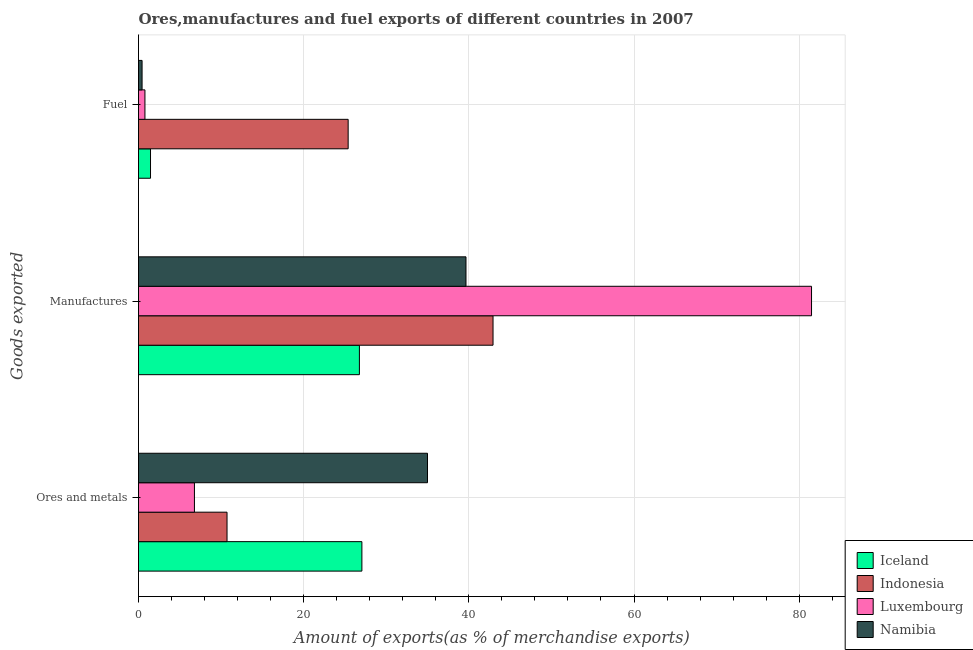How many bars are there on the 3rd tick from the top?
Your answer should be compact. 4. What is the label of the 3rd group of bars from the top?
Offer a very short reply. Ores and metals. What is the percentage of manufactures exports in Luxembourg?
Offer a very short reply. 81.5. Across all countries, what is the maximum percentage of ores and metals exports?
Keep it short and to the point. 34.99. Across all countries, what is the minimum percentage of ores and metals exports?
Keep it short and to the point. 6.77. In which country was the percentage of manufactures exports maximum?
Make the answer very short. Luxembourg. In which country was the percentage of fuel exports minimum?
Your answer should be compact. Namibia. What is the total percentage of ores and metals exports in the graph?
Keep it short and to the point. 79.54. What is the difference between the percentage of fuel exports in Indonesia and that in Iceland?
Provide a succinct answer. 23.93. What is the difference between the percentage of ores and metals exports in Namibia and the percentage of fuel exports in Iceland?
Provide a succinct answer. 33.54. What is the average percentage of fuel exports per country?
Keep it short and to the point. 7.01. What is the difference between the percentage of manufactures exports and percentage of fuel exports in Namibia?
Keep it short and to the point. 39.22. What is the ratio of the percentage of ores and metals exports in Indonesia to that in Iceland?
Ensure brevity in your answer.  0.4. Is the percentage of manufactures exports in Namibia less than that in Luxembourg?
Offer a very short reply. Yes. Is the difference between the percentage of fuel exports in Luxembourg and Indonesia greater than the difference between the percentage of manufactures exports in Luxembourg and Indonesia?
Make the answer very short. No. What is the difference between the highest and the second highest percentage of ores and metals exports?
Offer a terse response. 7.94. What is the difference between the highest and the lowest percentage of ores and metals exports?
Your response must be concise. 28.22. Is the sum of the percentage of manufactures exports in Iceland and Indonesia greater than the maximum percentage of fuel exports across all countries?
Your answer should be compact. Yes. What does the 4th bar from the top in Manufactures represents?
Keep it short and to the point. Iceland. Is it the case that in every country, the sum of the percentage of ores and metals exports and percentage of manufactures exports is greater than the percentage of fuel exports?
Your answer should be compact. Yes. How many bars are there?
Provide a short and direct response. 12. What is the difference between two consecutive major ticks on the X-axis?
Offer a terse response. 20. Are the values on the major ticks of X-axis written in scientific E-notation?
Provide a short and direct response. No. What is the title of the graph?
Your response must be concise. Ores,manufactures and fuel exports of different countries in 2007. Does "Paraguay" appear as one of the legend labels in the graph?
Your answer should be very brief. No. What is the label or title of the X-axis?
Offer a terse response. Amount of exports(as % of merchandise exports). What is the label or title of the Y-axis?
Your answer should be compact. Goods exported. What is the Amount of exports(as % of merchandise exports) in Iceland in Ores and metals?
Your answer should be compact. 27.05. What is the Amount of exports(as % of merchandise exports) in Indonesia in Ores and metals?
Offer a terse response. 10.72. What is the Amount of exports(as % of merchandise exports) in Luxembourg in Ores and metals?
Offer a very short reply. 6.77. What is the Amount of exports(as % of merchandise exports) of Namibia in Ores and metals?
Your answer should be compact. 34.99. What is the Amount of exports(as % of merchandise exports) in Iceland in Manufactures?
Offer a terse response. 26.75. What is the Amount of exports(as % of merchandise exports) of Indonesia in Manufactures?
Provide a succinct answer. 42.93. What is the Amount of exports(as % of merchandise exports) of Luxembourg in Manufactures?
Make the answer very short. 81.5. What is the Amount of exports(as % of merchandise exports) in Namibia in Manufactures?
Give a very brief answer. 39.66. What is the Amount of exports(as % of merchandise exports) of Iceland in Fuel?
Give a very brief answer. 1.45. What is the Amount of exports(as % of merchandise exports) of Indonesia in Fuel?
Provide a succinct answer. 25.39. What is the Amount of exports(as % of merchandise exports) in Luxembourg in Fuel?
Give a very brief answer. 0.78. What is the Amount of exports(as % of merchandise exports) in Namibia in Fuel?
Give a very brief answer. 0.43. Across all Goods exported, what is the maximum Amount of exports(as % of merchandise exports) of Iceland?
Offer a terse response. 27.05. Across all Goods exported, what is the maximum Amount of exports(as % of merchandise exports) of Indonesia?
Make the answer very short. 42.93. Across all Goods exported, what is the maximum Amount of exports(as % of merchandise exports) in Luxembourg?
Give a very brief answer. 81.5. Across all Goods exported, what is the maximum Amount of exports(as % of merchandise exports) in Namibia?
Your answer should be very brief. 39.66. Across all Goods exported, what is the minimum Amount of exports(as % of merchandise exports) in Iceland?
Ensure brevity in your answer.  1.45. Across all Goods exported, what is the minimum Amount of exports(as % of merchandise exports) in Indonesia?
Your answer should be compact. 10.72. Across all Goods exported, what is the minimum Amount of exports(as % of merchandise exports) of Luxembourg?
Ensure brevity in your answer.  0.78. Across all Goods exported, what is the minimum Amount of exports(as % of merchandise exports) of Namibia?
Offer a terse response. 0.43. What is the total Amount of exports(as % of merchandise exports) in Iceland in the graph?
Make the answer very short. 55.25. What is the total Amount of exports(as % of merchandise exports) of Indonesia in the graph?
Give a very brief answer. 79.04. What is the total Amount of exports(as % of merchandise exports) in Luxembourg in the graph?
Your answer should be compact. 89.05. What is the total Amount of exports(as % of merchandise exports) in Namibia in the graph?
Your answer should be very brief. 75.08. What is the difference between the Amount of exports(as % of merchandise exports) in Iceland in Ores and metals and that in Manufactures?
Your answer should be compact. 0.3. What is the difference between the Amount of exports(as % of merchandise exports) in Indonesia in Ores and metals and that in Manufactures?
Offer a very short reply. -32.21. What is the difference between the Amount of exports(as % of merchandise exports) in Luxembourg in Ores and metals and that in Manufactures?
Provide a short and direct response. -74.73. What is the difference between the Amount of exports(as % of merchandise exports) of Namibia in Ores and metals and that in Manufactures?
Keep it short and to the point. -4.66. What is the difference between the Amount of exports(as % of merchandise exports) of Iceland in Ores and metals and that in Fuel?
Make the answer very short. 25.6. What is the difference between the Amount of exports(as % of merchandise exports) in Indonesia in Ores and metals and that in Fuel?
Your answer should be compact. -14.67. What is the difference between the Amount of exports(as % of merchandise exports) in Luxembourg in Ores and metals and that in Fuel?
Keep it short and to the point. 5.99. What is the difference between the Amount of exports(as % of merchandise exports) in Namibia in Ores and metals and that in Fuel?
Your answer should be compact. 34.56. What is the difference between the Amount of exports(as % of merchandise exports) of Iceland in Manufactures and that in Fuel?
Provide a succinct answer. 25.3. What is the difference between the Amount of exports(as % of merchandise exports) of Indonesia in Manufactures and that in Fuel?
Offer a very short reply. 17.54. What is the difference between the Amount of exports(as % of merchandise exports) of Luxembourg in Manufactures and that in Fuel?
Keep it short and to the point. 80.72. What is the difference between the Amount of exports(as % of merchandise exports) in Namibia in Manufactures and that in Fuel?
Your answer should be very brief. 39.22. What is the difference between the Amount of exports(as % of merchandise exports) in Iceland in Ores and metals and the Amount of exports(as % of merchandise exports) in Indonesia in Manufactures?
Make the answer very short. -15.88. What is the difference between the Amount of exports(as % of merchandise exports) in Iceland in Ores and metals and the Amount of exports(as % of merchandise exports) in Luxembourg in Manufactures?
Offer a terse response. -54.45. What is the difference between the Amount of exports(as % of merchandise exports) of Iceland in Ores and metals and the Amount of exports(as % of merchandise exports) of Namibia in Manufactures?
Your response must be concise. -12.61. What is the difference between the Amount of exports(as % of merchandise exports) in Indonesia in Ores and metals and the Amount of exports(as % of merchandise exports) in Luxembourg in Manufactures?
Keep it short and to the point. -70.78. What is the difference between the Amount of exports(as % of merchandise exports) in Indonesia in Ores and metals and the Amount of exports(as % of merchandise exports) in Namibia in Manufactures?
Your answer should be compact. -28.94. What is the difference between the Amount of exports(as % of merchandise exports) in Luxembourg in Ores and metals and the Amount of exports(as % of merchandise exports) in Namibia in Manufactures?
Your answer should be compact. -32.88. What is the difference between the Amount of exports(as % of merchandise exports) in Iceland in Ores and metals and the Amount of exports(as % of merchandise exports) in Indonesia in Fuel?
Provide a succinct answer. 1.66. What is the difference between the Amount of exports(as % of merchandise exports) in Iceland in Ores and metals and the Amount of exports(as % of merchandise exports) in Luxembourg in Fuel?
Ensure brevity in your answer.  26.27. What is the difference between the Amount of exports(as % of merchandise exports) in Iceland in Ores and metals and the Amount of exports(as % of merchandise exports) in Namibia in Fuel?
Keep it short and to the point. 26.62. What is the difference between the Amount of exports(as % of merchandise exports) of Indonesia in Ores and metals and the Amount of exports(as % of merchandise exports) of Luxembourg in Fuel?
Your answer should be compact. 9.94. What is the difference between the Amount of exports(as % of merchandise exports) in Indonesia in Ores and metals and the Amount of exports(as % of merchandise exports) in Namibia in Fuel?
Provide a succinct answer. 10.29. What is the difference between the Amount of exports(as % of merchandise exports) in Luxembourg in Ores and metals and the Amount of exports(as % of merchandise exports) in Namibia in Fuel?
Your response must be concise. 6.34. What is the difference between the Amount of exports(as % of merchandise exports) of Iceland in Manufactures and the Amount of exports(as % of merchandise exports) of Indonesia in Fuel?
Your answer should be compact. 1.36. What is the difference between the Amount of exports(as % of merchandise exports) in Iceland in Manufactures and the Amount of exports(as % of merchandise exports) in Luxembourg in Fuel?
Provide a short and direct response. 25.97. What is the difference between the Amount of exports(as % of merchandise exports) in Iceland in Manufactures and the Amount of exports(as % of merchandise exports) in Namibia in Fuel?
Your answer should be compact. 26.32. What is the difference between the Amount of exports(as % of merchandise exports) in Indonesia in Manufactures and the Amount of exports(as % of merchandise exports) in Luxembourg in Fuel?
Your answer should be very brief. 42.15. What is the difference between the Amount of exports(as % of merchandise exports) of Indonesia in Manufactures and the Amount of exports(as % of merchandise exports) of Namibia in Fuel?
Give a very brief answer. 42.5. What is the difference between the Amount of exports(as % of merchandise exports) of Luxembourg in Manufactures and the Amount of exports(as % of merchandise exports) of Namibia in Fuel?
Offer a very short reply. 81.07. What is the average Amount of exports(as % of merchandise exports) in Iceland per Goods exported?
Offer a terse response. 18.42. What is the average Amount of exports(as % of merchandise exports) of Indonesia per Goods exported?
Provide a short and direct response. 26.35. What is the average Amount of exports(as % of merchandise exports) in Luxembourg per Goods exported?
Offer a very short reply. 29.68. What is the average Amount of exports(as % of merchandise exports) of Namibia per Goods exported?
Offer a terse response. 25.03. What is the difference between the Amount of exports(as % of merchandise exports) of Iceland and Amount of exports(as % of merchandise exports) of Indonesia in Ores and metals?
Offer a terse response. 16.33. What is the difference between the Amount of exports(as % of merchandise exports) of Iceland and Amount of exports(as % of merchandise exports) of Luxembourg in Ores and metals?
Offer a very short reply. 20.28. What is the difference between the Amount of exports(as % of merchandise exports) in Iceland and Amount of exports(as % of merchandise exports) in Namibia in Ores and metals?
Your answer should be very brief. -7.94. What is the difference between the Amount of exports(as % of merchandise exports) in Indonesia and Amount of exports(as % of merchandise exports) in Luxembourg in Ores and metals?
Give a very brief answer. 3.95. What is the difference between the Amount of exports(as % of merchandise exports) of Indonesia and Amount of exports(as % of merchandise exports) of Namibia in Ores and metals?
Ensure brevity in your answer.  -24.28. What is the difference between the Amount of exports(as % of merchandise exports) of Luxembourg and Amount of exports(as % of merchandise exports) of Namibia in Ores and metals?
Provide a succinct answer. -28.22. What is the difference between the Amount of exports(as % of merchandise exports) of Iceland and Amount of exports(as % of merchandise exports) of Indonesia in Manufactures?
Your answer should be very brief. -16.18. What is the difference between the Amount of exports(as % of merchandise exports) of Iceland and Amount of exports(as % of merchandise exports) of Luxembourg in Manufactures?
Your response must be concise. -54.75. What is the difference between the Amount of exports(as % of merchandise exports) of Iceland and Amount of exports(as % of merchandise exports) of Namibia in Manufactures?
Keep it short and to the point. -12.91. What is the difference between the Amount of exports(as % of merchandise exports) of Indonesia and Amount of exports(as % of merchandise exports) of Luxembourg in Manufactures?
Your answer should be compact. -38.57. What is the difference between the Amount of exports(as % of merchandise exports) of Indonesia and Amount of exports(as % of merchandise exports) of Namibia in Manufactures?
Keep it short and to the point. 3.27. What is the difference between the Amount of exports(as % of merchandise exports) in Luxembourg and Amount of exports(as % of merchandise exports) in Namibia in Manufactures?
Offer a terse response. 41.84. What is the difference between the Amount of exports(as % of merchandise exports) of Iceland and Amount of exports(as % of merchandise exports) of Indonesia in Fuel?
Keep it short and to the point. -23.93. What is the difference between the Amount of exports(as % of merchandise exports) of Iceland and Amount of exports(as % of merchandise exports) of Luxembourg in Fuel?
Your answer should be compact. 0.68. What is the difference between the Amount of exports(as % of merchandise exports) of Iceland and Amount of exports(as % of merchandise exports) of Namibia in Fuel?
Offer a very short reply. 1.02. What is the difference between the Amount of exports(as % of merchandise exports) of Indonesia and Amount of exports(as % of merchandise exports) of Luxembourg in Fuel?
Offer a very short reply. 24.61. What is the difference between the Amount of exports(as % of merchandise exports) in Indonesia and Amount of exports(as % of merchandise exports) in Namibia in Fuel?
Provide a succinct answer. 24.96. What is the difference between the Amount of exports(as % of merchandise exports) of Luxembourg and Amount of exports(as % of merchandise exports) of Namibia in Fuel?
Give a very brief answer. 0.35. What is the ratio of the Amount of exports(as % of merchandise exports) in Iceland in Ores and metals to that in Manufactures?
Your answer should be very brief. 1.01. What is the ratio of the Amount of exports(as % of merchandise exports) in Indonesia in Ores and metals to that in Manufactures?
Ensure brevity in your answer.  0.25. What is the ratio of the Amount of exports(as % of merchandise exports) of Luxembourg in Ores and metals to that in Manufactures?
Ensure brevity in your answer.  0.08. What is the ratio of the Amount of exports(as % of merchandise exports) in Namibia in Ores and metals to that in Manufactures?
Offer a very short reply. 0.88. What is the ratio of the Amount of exports(as % of merchandise exports) in Iceland in Ores and metals to that in Fuel?
Offer a terse response. 18.61. What is the ratio of the Amount of exports(as % of merchandise exports) of Indonesia in Ores and metals to that in Fuel?
Give a very brief answer. 0.42. What is the ratio of the Amount of exports(as % of merchandise exports) of Luxembourg in Ores and metals to that in Fuel?
Your answer should be very brief. 8.7. What is the ratio of the Amount of exports(as % of merchandise exports) of Namibia in Ores and metals to that in Fuel?
Offer a terse response. 81.08. What is the ratio of the Amount of exports(as % of merchandise exports) in Iceland in Manufactures to that in Fuel?
Ensure brevity in your answer.  18.4. What is the ratio of the Amount of exports(as % of merchandise exports) in Indonesia in Manufactures to that in Fuel?
Provide a short and direct response. 1.69. What is the ratio of the Amount of exports(as % of merchandise exports) of Luxembourg in Manufactures to that in Fuel?
Offer a terse response. 104.65. What is the ratio of the Amount of exports(as % of merchandise exports) of Namibia in Manufactures to that in Fuel?
Provide a short and direct response. 91.88. What is the difference between the highest and the second highest Amount of exports(as % of merchandise exports) in Iceland?
Your response must be concise. 0.3. What is the difference between the highest and the second highest Amount of exports(as % of merchandise exports) in Indonesia?
Provide a short and direct response. 17.54. What is the difference between the highest and the second highest Amount of exports(as % of merchandise exports) in Luxembourg?
Ensure brevity in your answer.  74.73. What is the difference between the highest and the second highest Amount of exports(as % of merchandise exports) in Namibia?
Provide a succinct answer. 4.66. What is the difference between the highest and the lowest Amount of exports(as % of merchandise exports) of Iceland?
Your response must be concise. 25.6. What is the difference between the highest and the lowest Amount of exports(as % of merchandise exports) of Indonesia?
Offer a terse response. 32.21. What is the difference between the highest and the lowest Amount of exports(as % of merchandise exports) in Luxembourg?
Offer a terse response. 80.72. What is the difference between the highest and the lowest Amount of exports(as % of merchandise exports) of Namibia?
Offer a very short reply. 39.22. 